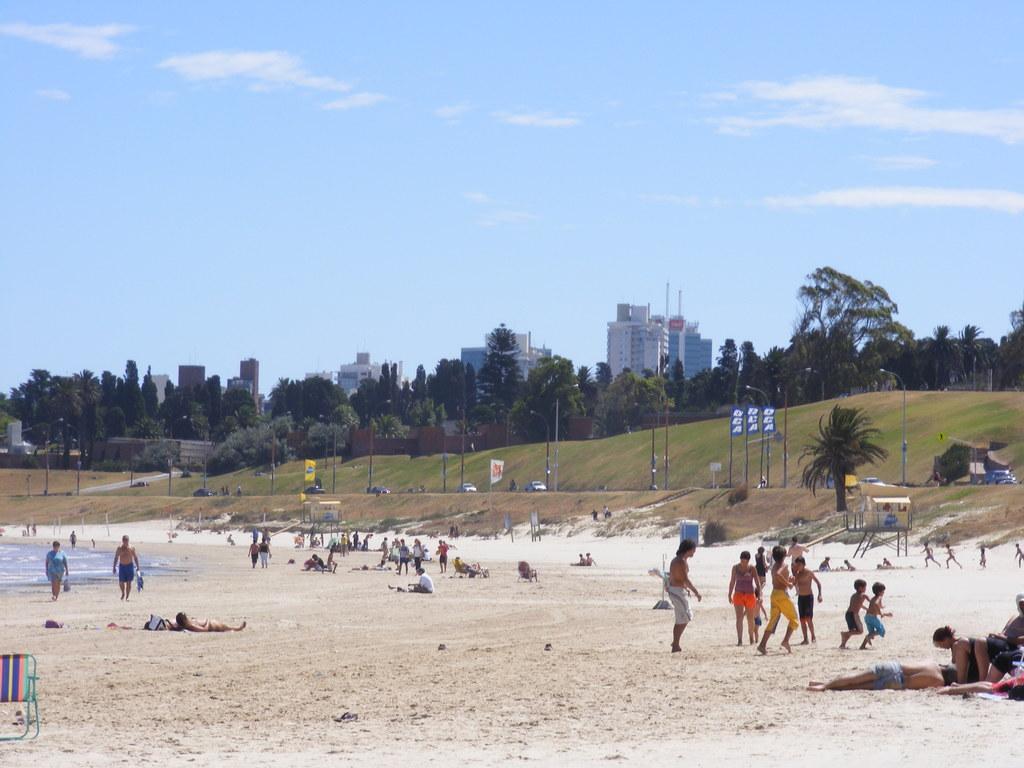Please provide a concise description of this image. In the foreground of the image there are people on the seashore. In the background of the image there are trees. There are buildings. At the top of the image there is sky. There is grass. 